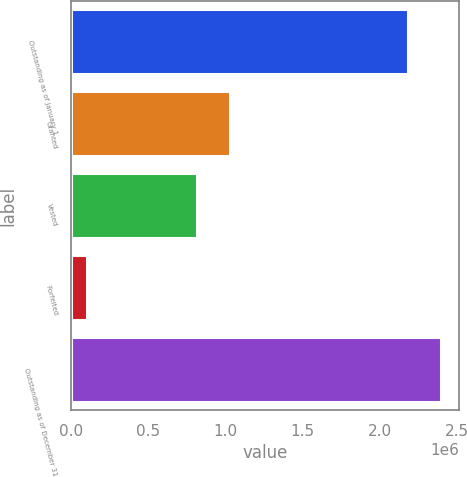Convert chart to OTSL. <chart><loc_0><loc_0><loc_500><loc_500><bar_chart><fcel>Outstanding as of January 1<fcel>Granted<fcel>Vested<fcel>Forfeited<fcel>Outstanding as of December 31<nl><fcel>2.18042e+06<fcel>1.0275e+06<fcel>815851<fcel>100099<fcel>2.39207e+06<nl></chart> 